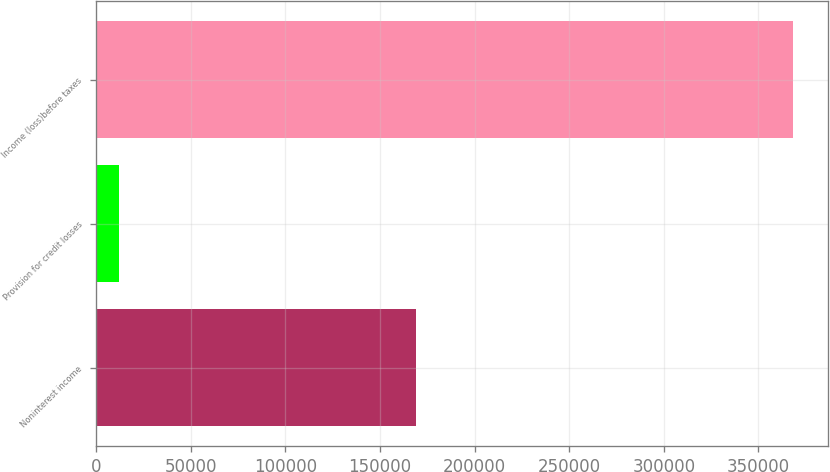Convert chart. <chart><loc_0><loc_0><loc_500><loc_500><bar_chart><fcel>Noninterest income<fcel>Provision for credit losses<fcel>Income (loss)before taxes<nl><fcel>169157<fcel>12190<fcel>368424<nl></chart> 